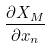Convert formula to latex. <formula><loc_0><loc_0><loc_500><loc_500>\frac { \partial X _ { M } } { \partial x _ { n } }</formula> 